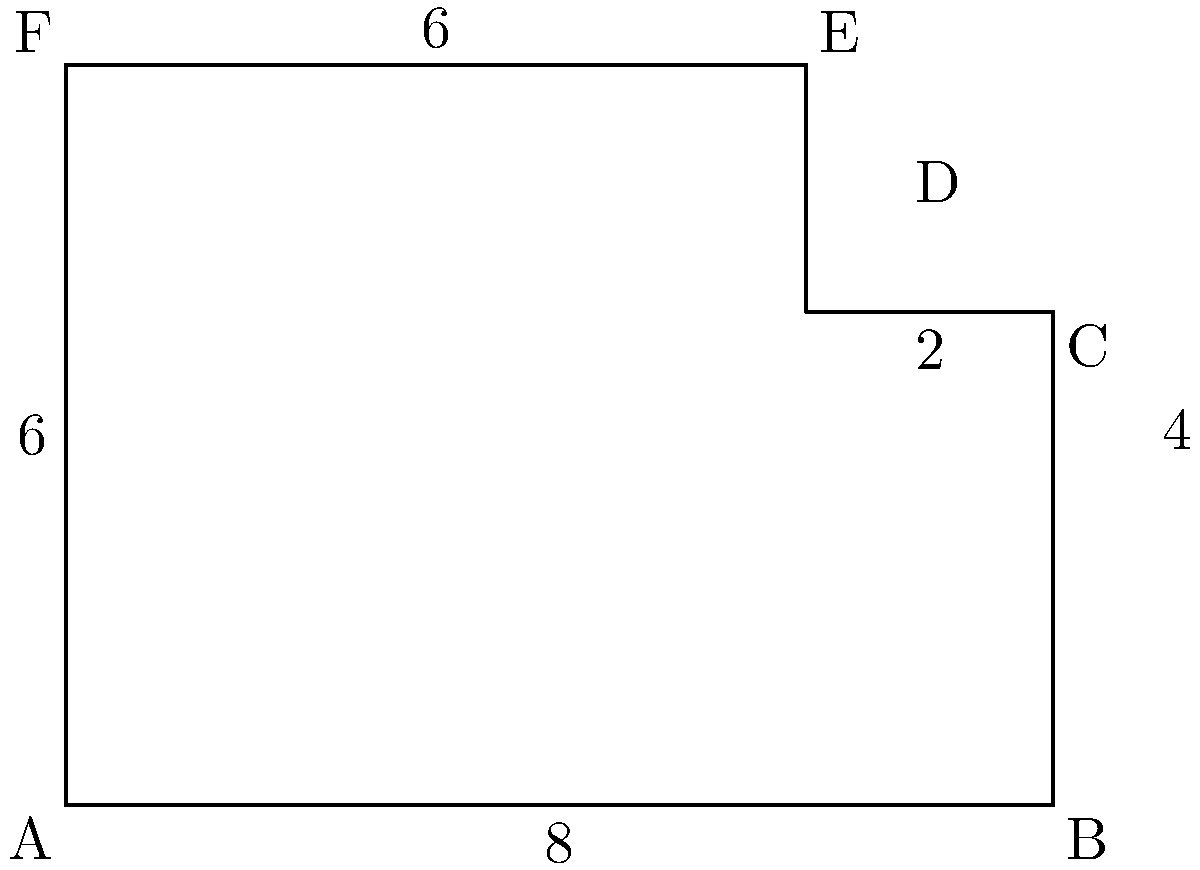Stacey is designing a unique classroom layout for her students. The floor plan is represented by the composite shape ABCDEF shown above. If the units are in meters, what is the total area of this classroom in square meters? Let's break this down step-by-step:

1) The shape can be divided into a rectangle (ABCDF) and a triangle (CDE).

2) For the rectangle ABCDF:
   - Width = 6 m
   - Height = 6 m
   - Area of rectangle = $6 \times 6 = 36$ m²

3) For the triangle CDE:
   - Base = 2 m
   - Height = 2 m
   - Area of triangle = $\frac{1}{2} \times 2 \times 2 = 2$ m²

4) Total area = Area of rectangle + Area of triangle
               = $36 + 2 = 38$ m²

Therefore, the total area of Stacey's classroom is 38 square meters.
Answer: 38 m² 